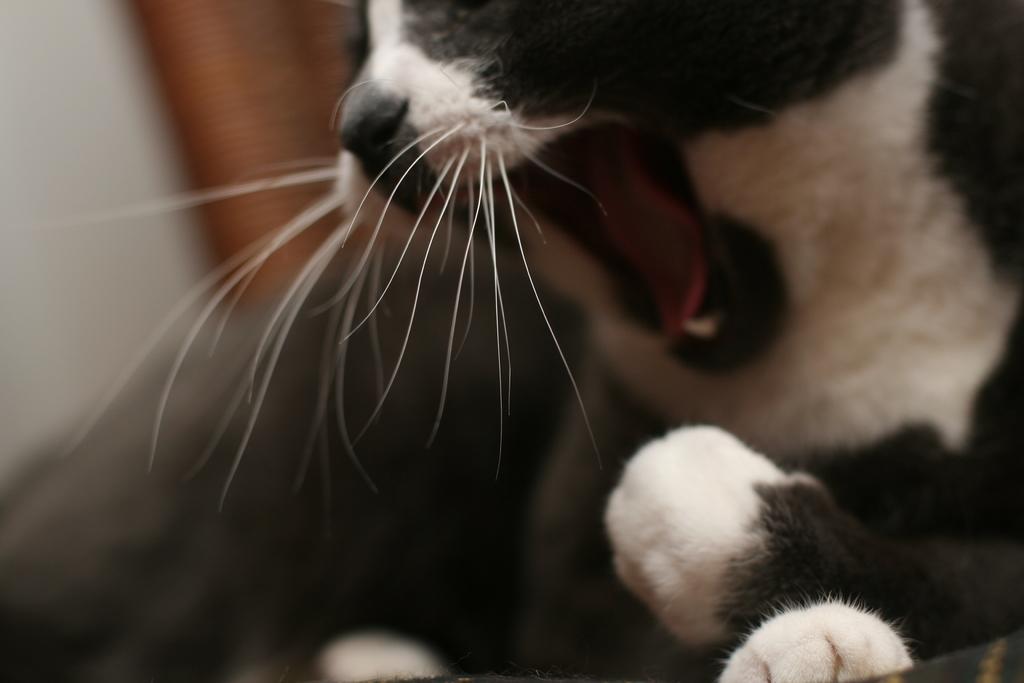Can you describe this image briefly? In this image I can see an animal which is in black and white color. And there is a blurred background. 